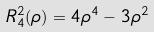Convert formula to latex. <formula><loc_0><loc_0><loc_500><loc_500>R _ { 4 } ^ { 2 } ( \rho ) = 4 \rho ^ { 4 } - 3 \rho ^ { 2 }</formula> 